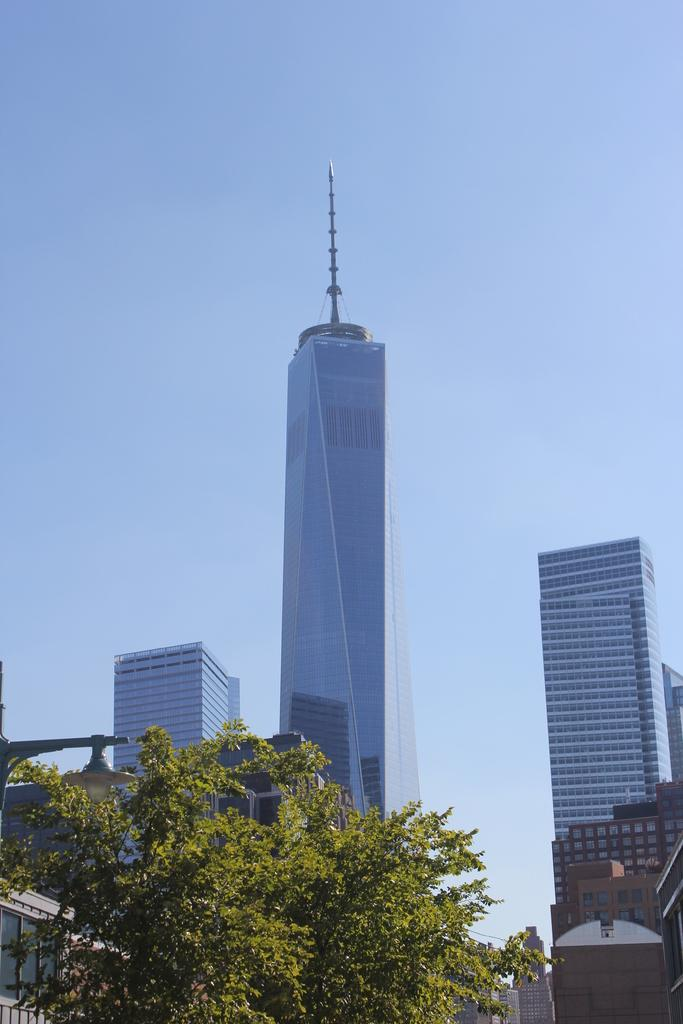What is located in the center of the image? There are buildings and trees in the center of the image. What can be seen at the top of the image? The sky is visible at the top of the image. What type of fiction is being read by the cloth in the image? There is no cloth or fiction present in the image. What type of play is being performed by the trees in the image? There is no play being performed by the trees in the image; they are simply standing in the center of the image. 